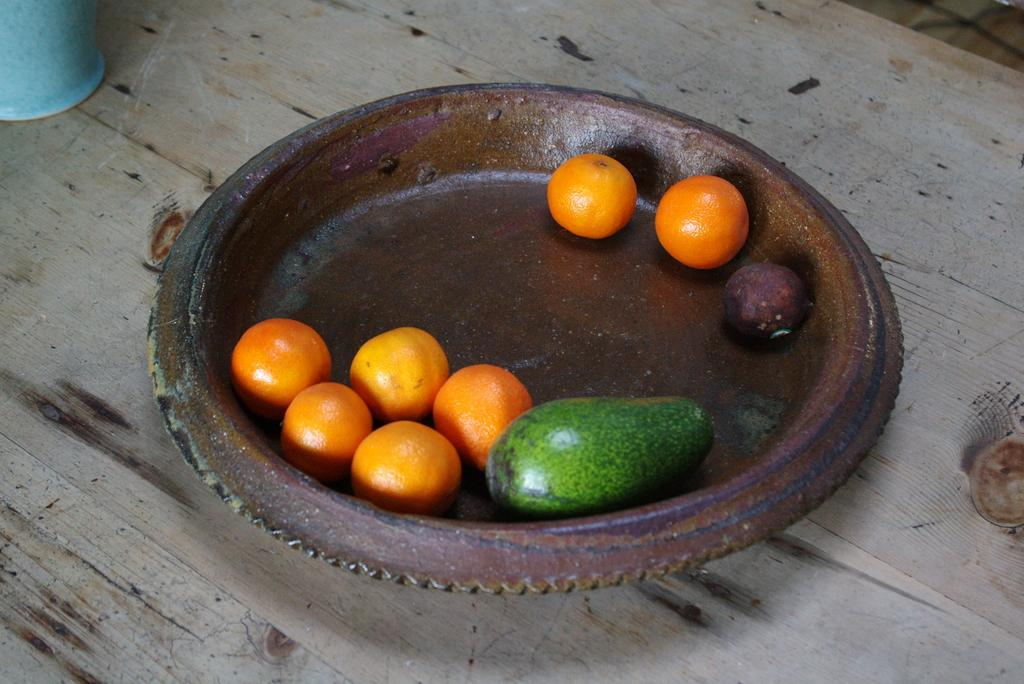What type of fruit can be seen in the image? There are oranges in the image. Are there any other types of fruit besides oranges? Yes, there are other fruits in the image. How are the fruits arranged or displayed in the image? The fruits are in a plate in the image. What else can be seen on the table in the image? There is a glass on the table in the image. How many legs does the judge have in the image? There is no judge present in the image, so it is not possible to determine the number of legs they might have. 